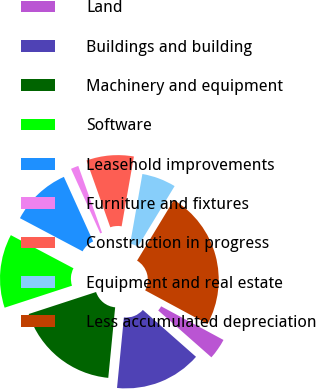<chart> <loc_0><loc_0><loc_500><loc_500><pie_chart><fcel>Land<fcel>Buildings and building<fcel>Machinery and equipment<fcel>Software<fcel>Leasehold improvements<fcel>Furniture and fixtures<fcel>Construction in progress<fcel>Equipment and real estate<fcel>Less accumulated depreciation<nl><fcel>3.62%<fcel>15.05%<fcel>18.43%<fcel>12.77%<fcel>10.48%<fcel>1.34%<fcel>8.2%<fcel>5.91%<fcel>24.2%<nl></chart> 